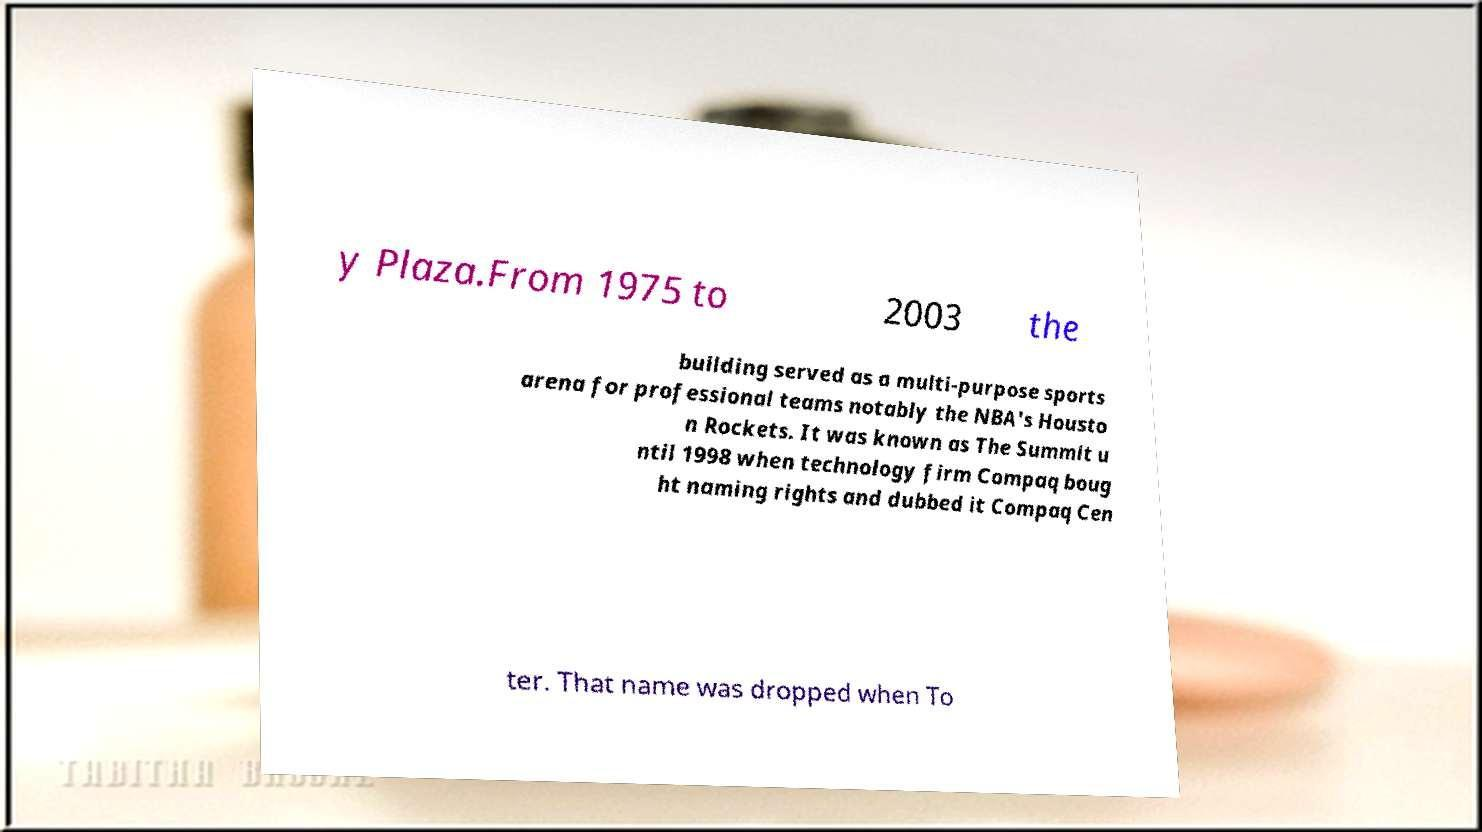For documentation purposes, I need the text within this image transcribed. Could you provide that? y Plaza.From 1975 to 2003 the building served as a multi-purpose sports arena for professional teams notably the NBA's Housto n Rockets. It was known as The Summit u ntil 1998 when technology firm Compaq boug ht naming rights and dubbed it Compaq Cen ter. That name was dropped when To 